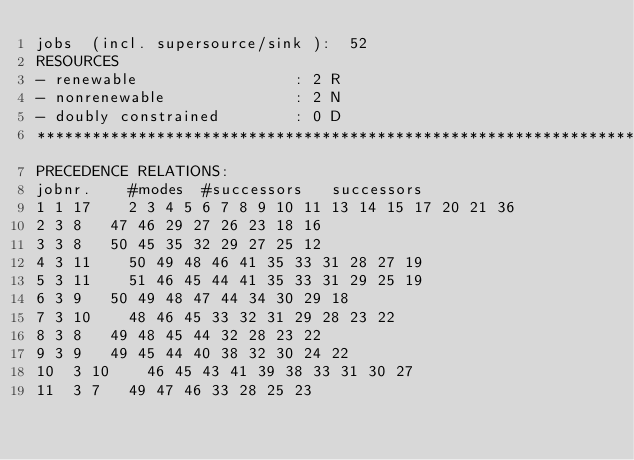<code> <loc_0><loc_0><loc_500><loc_500><_ObjectiveC_>jobs  (incl. supersource/sink ):	52
RESOURCES
- renewable                 : 2 R
- nonrenewable              : 2 N
- doubly constrained        : 0 D
************************************************************************
PRECEDENCE RELATIONS:
jobnr.    #modes  #successors   successors
1	1	17		2 3 4 5 6 7 8 9 10 11 13 14 15 17 20 21 36 
2	3	8		47 46 29 27 26 23 18 16 
3	3	8		50 45 35 32 29 27 25 12 
4	3	11		50 49 48 46 41 35 33 31 28 27 19 
5	3	11		51 46 45 44 41 35 33 31 29 25 19 
6	3	9		50 49 48 47 44 34 30 29 18 
7	3	10		48 46 45 33 32 31 29 28 23 22 
8	3	8		49 48 45 44 32 28 23 22 
9	3	9		49 45 44 40 38 32 30 24 22 
10	3	10		46 45 43 41 39 38 33 31 30 27 
11	3	7		49 47 46 33 28 25 23 </code> 